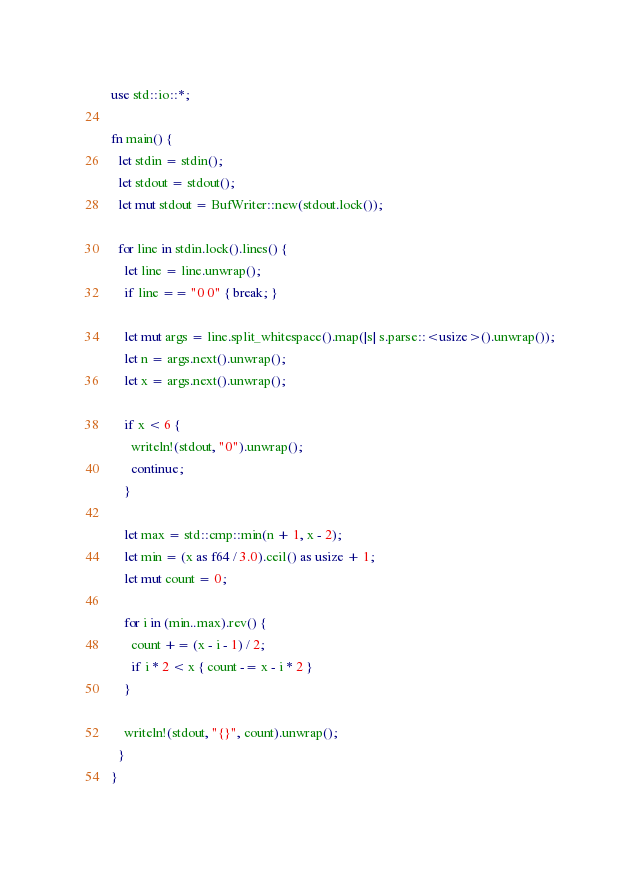Convert code to text. <code><loc_0><loc_0><loc_500><loc_500><_Rust_>use std::io::*;

fn main() {
  let stdin = stdin();
  let stdout = stdout();
  let mut stdout = BufWriter::new(stdout.lock());

  for line in stdin.lock().lines() {
    let line = line.unwrap();
    if line == "0 0" { break; }

    let mut args = line.split_whitespace().map(|s| s.parse::<usize>().unwrap());
    let n = args.next().unwrap();
    let x = args.next().unwrap();

    if x < 6 {
      writeln!(stdout, "0").unwrap();
      continue;
    }

    let max = std::cmp::min(n + 1, x - 2);
    let min = (x as f64 / 3.0).ceil() as usize + 1;
    let mut count = 0;

    for i in (min..max).rev() {
      count += (x - i - 1) / 2;
      if i * 2 < x { count -= x - i * 2 }
    }

    writeln!(stdout, "{}", count).unwrap();
  }
}

</code> 